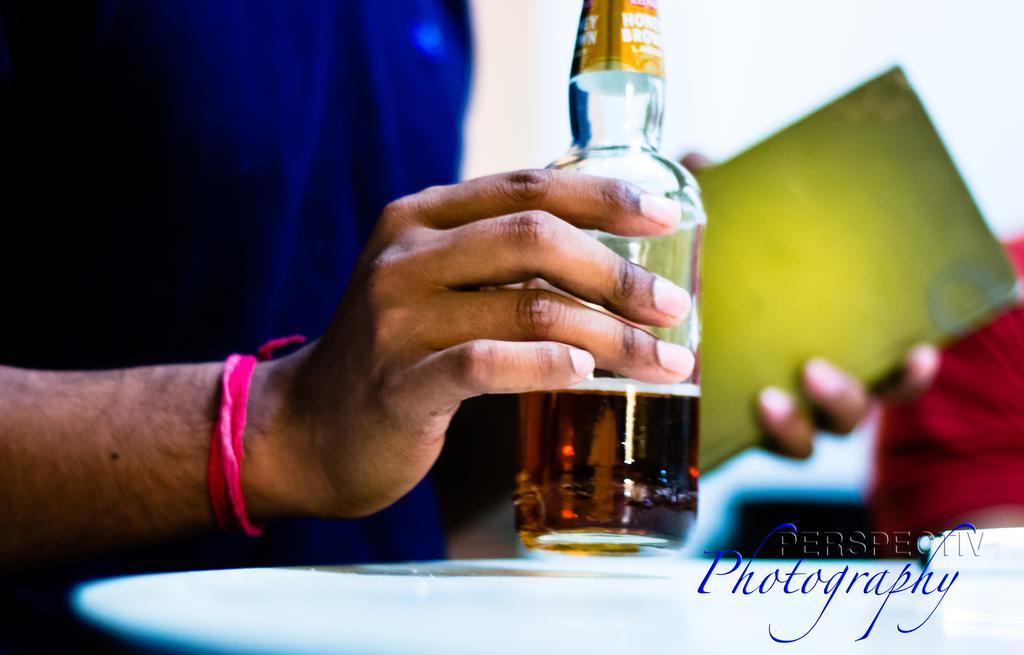<image>
Summarize the visual content of the image. A man is holding a bottle with a label that says "honey brown" on it. 